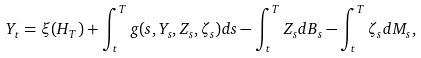<formula> <loc_0><loc_0><loc_500><loc_500>Y _ { t } = \xi ( H _ { T } ) + \int _ { t } ^ { T } g ( s , Y _ { s } , Z _ { s } , \zeta _ { s } ) d s - \int _ { t } ^ { T } Z _ { s } d B _ { s } - \int _ { t } ^ { T } \zeta _ { s } d M _ { s } ,</formula> 